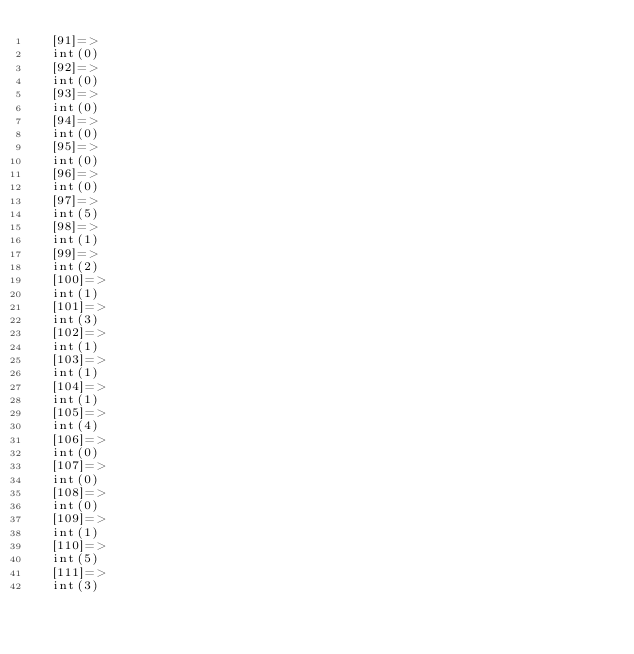<code> <loc_0><loc_0><loc_500><loc_500><_PHP_>  [91]=>
  int(0)
  [92]=>
  int(0)
  [93]=>
  int(0)
  [94]=>
  int(0)
  [95]=>
  int(0)
  [96]=>
  int(0)
  [97]=>
  int(5)
  [98]=>
  int(1)
  [99]=>
  int(2)
  [100]=>
  int(1)
  [101]=>
  int(3)
  [102]=>
  int(1)
  [103]=>
  int(1)
  [104]=>
  int(1)
  [105]=>
  int(4)
  [106]=>
  int(0)
  [107]=>
  int(0)
  [108]=>
  int(0)
  [109]=>
  int(1)
  [110]=>
  int(5)
  [111]=>
  int(3)</code> 